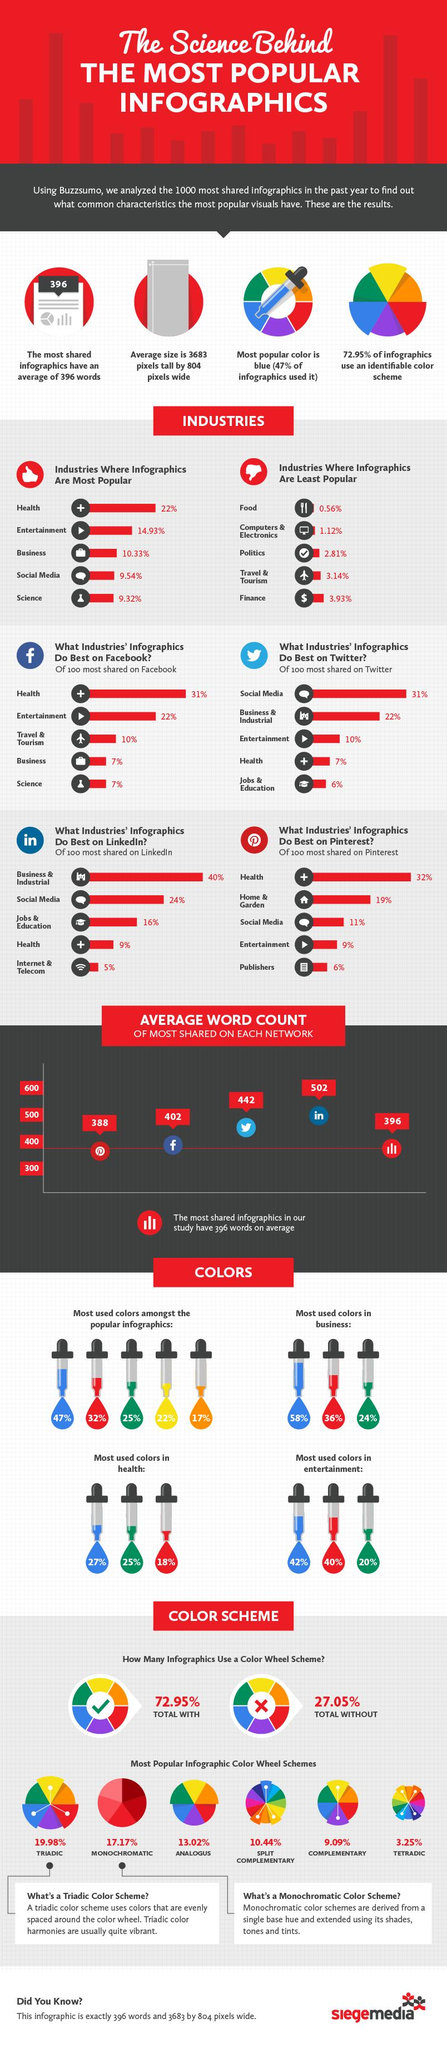Draw attention to some important aspects in this diagram. The analogous color wheel scheme was used in approximately 13.02% of the infographics. Blue, green, red, or yellow are the most frequently used colors in infographics by the business industry. However, red is the second most popular color. The most shared infographics on Twitter average 442 words. According to a study, only 7% of infographics based on business are shared on Facebook. According to a study, only 10% of infographics based on entertainment are shared on Twitter. 